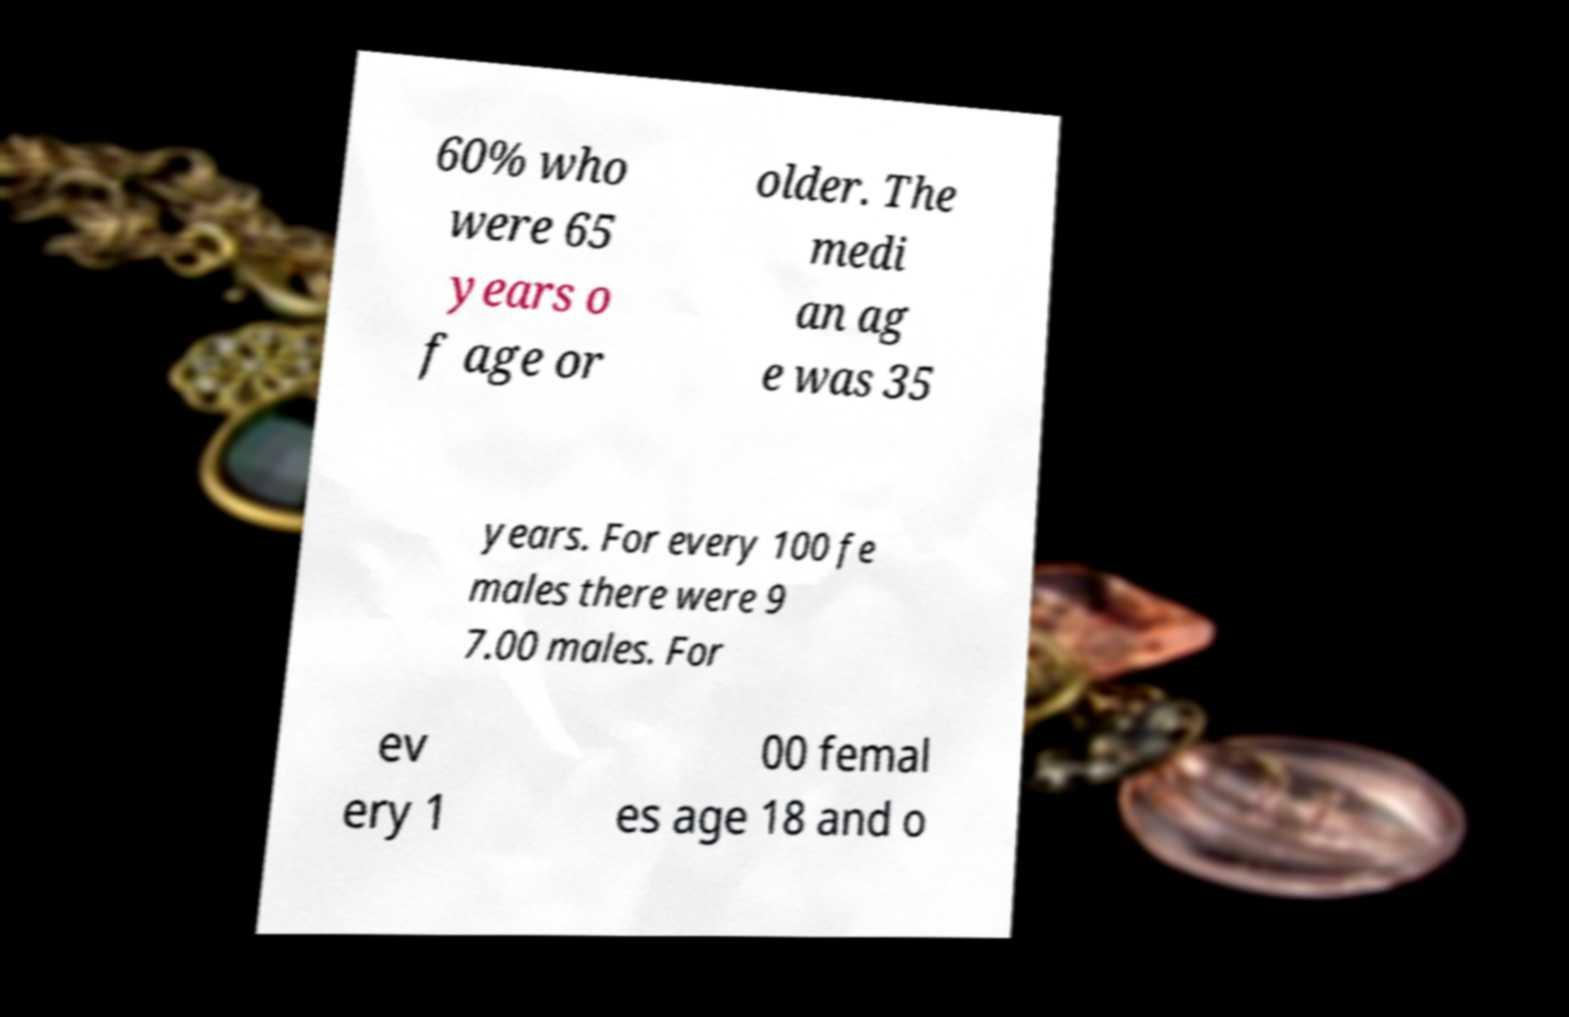What messages or text are displayed in this image? I need them in a readable, typed format. 60% who were 65 years o f age or older. The medi an ag e was 35 years. For every 100 fe males there were 9 7.00 males. For ev ery 1 00 femal es age 18 and o 